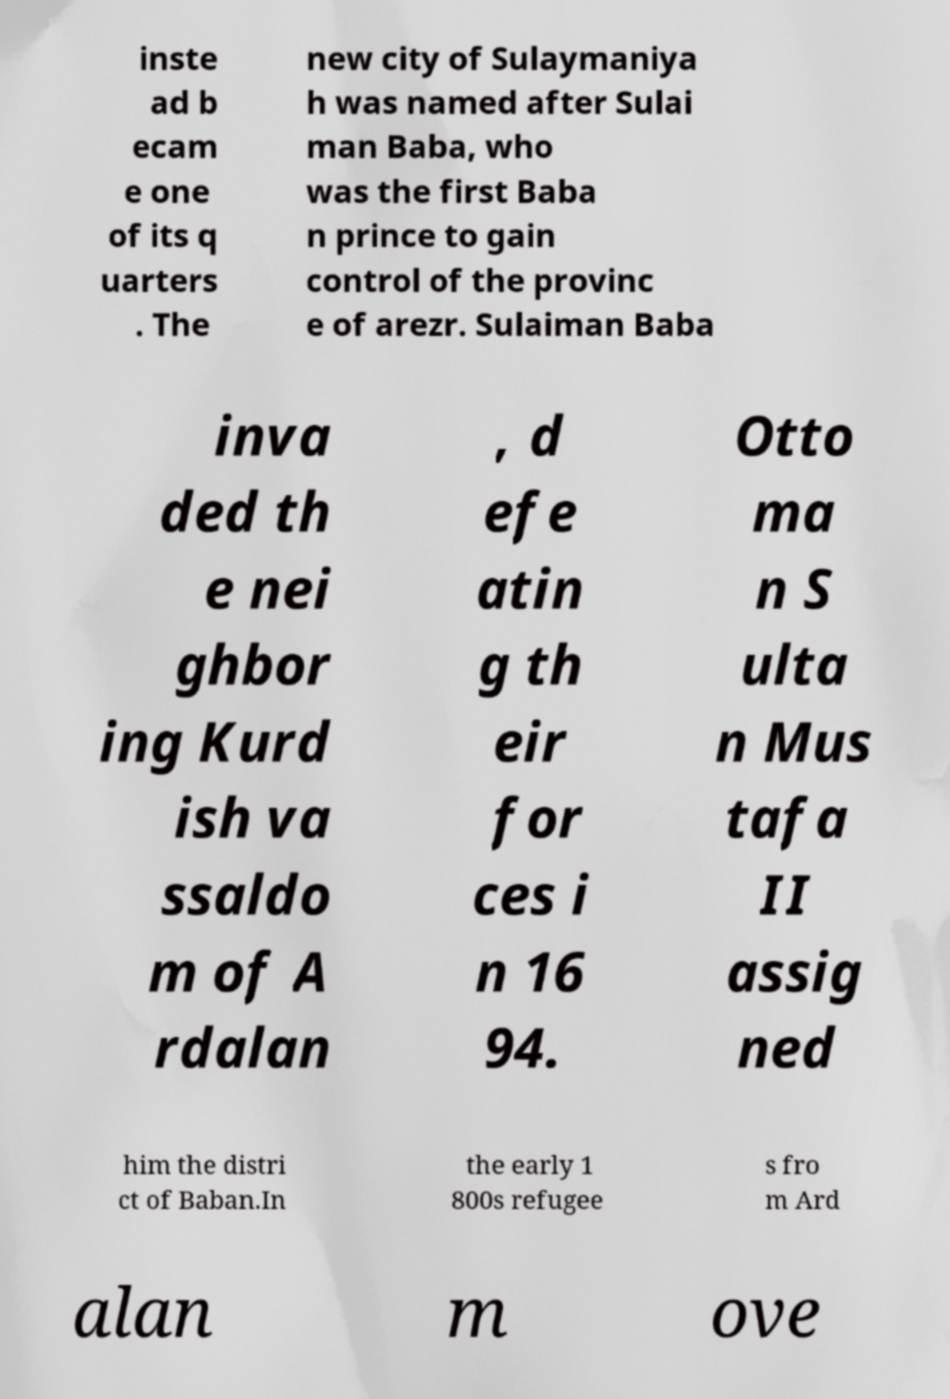I need the written content from this picture converted into text. Can you do that? inste ad b ecam e one of its q uarters . The new city of Sulaymaniya h was named after Sulai man Baba, who was the first Baba n prince to gain control of the provinc e of arezr. Sulaiman Baba inva ded th e nei ghbor ing Kurd ish va ssaldo m of A rdalan , d efe atin g th eir for ces i n 16 94. Otto ma n S ulta n Mus tafa II assig ned him the distri ct of Baban.In the early 1 800s refugee s fro m Ard alan m ove 